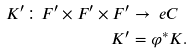<formula> <loc_0><loc_0><loc_500><loc_500>K ^ { \prime } \colon F ^ { \prime } \times F ^ { \prime } \times F ^ { \prime } & \to \ e C \\ K ^ { \prime } & = \varphi ^ { * } K .</formula> 